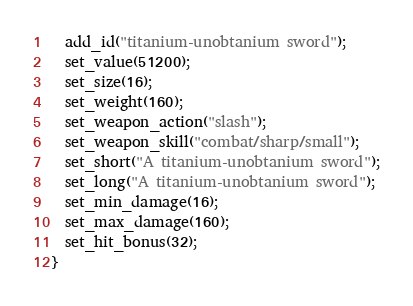Convert code to text. <code><loc_0><loc_0><loc_500><loc_500><_C_>  add_id("titanium-unobtanium sword");
  set_value(51200);
  set_size(16);
  set_weight(160);
  set_weapon_action("slash");
  set_weapon_skill("combat/sharp/small");
  set_short("A titanium-unobtanium sword");
  set_long("A titanium-unobtanium sword");
  set_min_damage(16);
  set_max_damage(160);
  set_hit_bonus(32);
}
</code> 